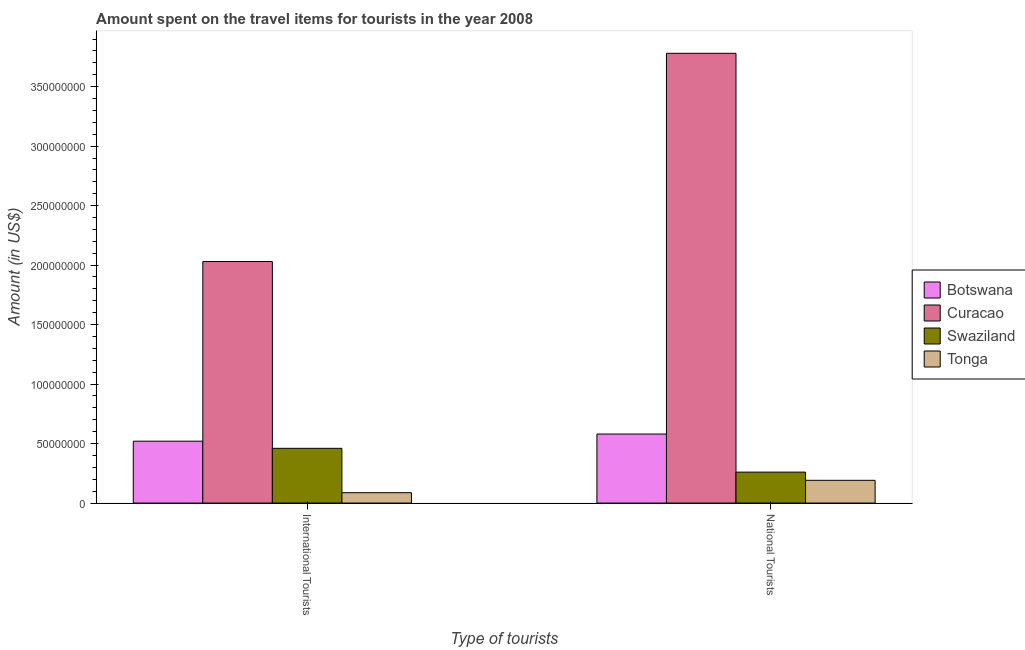How many different coloured bars are there?
Make the answer very short. 4. Are the number of bars on each tick of the X-axis equal?
Your response must be concise. Yes. How many bars are there on the 1st tick from the left?
Ensure brevity in your answer.  4. How many bars are there on the 2nd tick from the right?
Your answer should be very brief. 4. What is the label of the 2nd group of bars from the left?
Offer a terse response. National Tourists. What is the amount spent on travel items of national tourists in Swaziland?
Provide a succinct answer. 2.60e+07. Across all countries, what is the maximum amount spent on travel items of international tourists?
Provide a succinct answer. 2.03e+08. Across all countries, what is the minimum amount spent on travel items of international tourists?
Ensure brevity in your answer.  8.70e+06. In which country was the amount spent on travel items of national tourists maximum?
Keep it short and to the point. Curacao. In which country was the amount spent on travel items of national tourists minimum?
Provide a short and direct response. Tonga. What is the total amount spent on travel items of international tourists in the graph?
Your response must be concise. 3.10e+08. What is the difference between the amount spent on travel items of international tourists in Tonga and that in Swaziland?
Provide a short and direct response. -3.73e+07. What is the difference between the amount spent on travel items of national tourists in Curacao and the amount spent on travel items of international tourists in Botswana?
Give a very brief answer. 3.26e+08. What is the average amount spent on travel items of national tourists per country?
Ensure brevity in your answer.  1.20e+08. What is the difference between the amount spent on travel items of international tourists and amount spent on travel items of national tourists in Botswana?
Offer a very short reply. -6.00e+06. What is the ratio of the amount spent on travel items of international tourists in Swaziland to that in Tonga?
Provide a short and direct response. 5.29. Is the amount spent on travel items of international tourists in Botswana less than that in Tonga?
Offer a terse response. No. What does the 2nd bar from the left in International Tourists represents?
Ensure brevity in your answer.  Curacao. What does the 1st bar from the right in National Tourists represents?
Ensure brevity in your answer.  Tonga. Are all the bars in the graph horizontal?
Your answer should be very brief. No. How many countries are there in the graph?
Your answer should be very brief. 4. What is the difference between two consecutive major ticks on the Y-axis?
Provide a short and direct response. 5.00e+07. Where does the legend appear in the graph?
Your answer should be very brief. Center right. How many legend labels are there?
Your answer should be compact. 4. What is the title of the graph?
Provide a short and direct response. Amount spent on the travel items for tourists in the year 2008. Does "Ireland" appear as one of the legend labels in the graph?
Ensure brevity in your answer.  No. What is the label or title of the X-axis?
Provide a succinct answer. Type of tourists. What is the Amount (in US$) of Botswana in International Tourists?
Offer a very short reply. 5.20e+07. What is the Amount (in US$) in Curacao in International Tourists?
Provide a succinct answer. 2.03e+08. What is the Amount (in US$) of Swaziland in International Tourists?
Keep it short and to the point. 4.60e+07. What is the Amount (in US$) in Tonga in International Tourists?
Provide a succinct answer. 8.70e+06. What is the Amount (in US$) in Botswana in National Tourists?
Make the answer very short. 5.80e+07. What is the Amount (in US$) of Curacao in National Tourists?
Keep it short and to the point. 3.78e+08. What is the Amount (in US$) of Swaziland in National Tourists?
Provide a succinct answer. 2.60e+07. What is the Amount (in US$) of Tonga in National Tourists?
Your answer should be compact. 1.91e+07. Across all Type of tourists, what is the maximum Amount (in US$) of Botswana?
Provide a short and direct response. 5.80e+07. Across all Type of tourists, what is the maximum Amount (in US$) of Curacao?
Provide a succinct answer. 3.78e+08. Across all Type of tourists, what is the maximum Amount (in US$) of Swaziland?
Your answer should be very brief. 4.60e+07. Across all Type of tourists, what is the maximum Amount (in US$) of Tonga?
Your answer should be compact. 1.91e+07. Across all Type of tourists, what is the minimum Amount (in US$) in Botswana?
Provide a short and direct response. 5.20e+07. Across all Type of tourists, what is the minimum Amount (in US$) in Curacao?
Keep it short and to the point. 2.03e+08. Across all Type of tourists, what is the minimum Amount (in US$) in Swaziland?
Provide a succinct answer. 2.60e+07. Across all Type of tourists, what is the minimum Amount (in US$) in Tonga?
Your answer should be very brief. 8.70e+06. What is the total Amount (in US$) in Botswana in the graph?
Make the answer very short. 1.10e+08. What is the total Amount (in US$) in Curacao in the graph?
Ensure brevity in your answer.  5.81e+08. What is the total Amount (in US$) in Swaziland in the graph?
Offer a very short reply. 7.20e+07. What is the total Amount (in US$) of Tonga in the graph?
Make the answer very short. 2.78e+07. What is the difference between the Amount (in US$) in Botswana in International Tourists and that in National Tourists?
Give a very brief answer. -6.00e+06. What is the difference between the Amount (in US$) in Curacao in International Tourists and that in National Tourists?
Offer a very short reply. -1.75e+08. What is the difference between the Amount (in US$) of Tonga in International Tourists and that in National Tourists?
Keep it short and to the point. -1.04e+07. What is the difference between the Amount (in US$) of Botswana in International Tourists and the Amount (in US$) of Curacao in National Tourists?
Give a very brief answer. -3.26e+08. What is the difference between the Amount (in US$) in Botswana in International Tourists and the Amount (in US$) in Swaziland in National Tourists?
Make the answer very short. 2.60e+07. What is the difference between the Amount (in US$) in Botswana in International Tourists and the Amount (in US$) in Tonga in National Tourists?
Provide a succinct answer. 3.29e+07. What is the difference between the Amount (in US$) of Curacao in International Tourists and the Amount (in US$) of Swaziland in National Tourists?
Give a very brief answer. 1.77e+08. What is the difference between the Amount (in US$) in Curacao in International Tourists and the Amount (in US$) in Tonga in National Tourists?
Make the answer very short. 1.84e+08. What is the difference between the Amount (in US$) of Swaziland in International Tourists and the Amount (in US$) of Tonga in National Tourists?
Offer a terse response. 2.69e+07. What is the average Amount (in US$) of Botswana per Type of tourists?
Provide a short and direct response. 5.50e+07. What is the average Amount (in US$) of Curacao per Type of tourists?
Your answer should be compact. 2.90e+08. What is the average Amount (in US$) in Swaziland per Type of tourists?
Offer a terse response. 3.60e+07. What is the average Amount (in US$) of Tonga per Type of tourists?
Keep it short and to the point. 1.39e+07. What is the difference between the Amount (in US$) in Botswana and Amount (in US$) in Curacao in International Tourists?
Provide a succinct answer. -1.51e+08. What is the difference between the Amount (in US$) in Botswana and Amount (in US$) in Tonga in International Tourists?
Give a very brief answer. 4.33e+07. What is the difference between the Amount (in US$) in Curacao and Amount (in US$) in Swaziland in International Tourists?
Provide a short and direct response. 1.57e+08. What is the difference between the Amount (in US$) in Curacao and Amount (in US$) in Tonga in International Tourists?
Ensure brevity in your answer.  1.94e+08. What is the difference between the Amount (in US$) in Swaziland and Amount (in US$) in Tonga in International Tourists?
Provide a succinct answer. 3.73e+07. What is the difference between the Amount (in US$) in Botswana and Amount (in US$) in Curacao in National Tourists?
Provide a short and direct response. -3.20e+08. What is the difference between the Amount (in US$) of Botswana and Amount (in US$) of Swaziland in National Tourists?
Keep it short and to the point. 3.20e+07. What is the difference between the Amount (in US$) in Botswana and Amount (in US$) in Tonga in National Tourists?
Provide a short and direct response. 3.89e+07. What is the difference between the Amount (in US$) in Curacao and Amount (in US$) in Swaziland in National Tourists?
Give a very brief answer. 3.52e+08. What is the difference between the Amount (in US$) in Curacao and Amount (in US$) in Tonga in National Tourists?
Provide a short and direct response. 3.59e+08. What is the difference between the Amount (in US$) of Swaziland and Amount (in US$) of Tonga in National Tourists?
Provide a succinct answer. 6.90e+06. What is the ratio of the Amount (in US$) of Botswana in International Tourists to that in National Tourists?
Provide a short and direct response. 0.9. What is the ratio of the Amount (in US$) of Curacao in International Tourists to that in National Tourists?
Your response must be concise. 0.54. What is the ratio of the Amount (in US$) in Swaziland in International Tourists to that in National Tourists?
Keep it short and to the point. 1.77. What is the ratio of the Amount (in US$) of Tonga in International Tourists to that in National Tourists?
Provide a short and direct response. 0.46. What is the difference between the highest and the second highest Amount (in US$) of Curacao?
Offer a terse response. 1.75e+08. What is the difference between the highest and the second highest Amount (in US$) in Swaziland?
Offer a terse response. 2.00e+07. What is the difference between the highest and the second highest Amount (in US$) of Tonga?
Provide a short and direct response. 1.04e+07. What is the difference between the highest and the lowest Amount (in US$) in Curacao?
Offer a very short reply. 1.75e+08. What is the difference between the highest and the lowest Amount (in US$) of Tonga?
Ensure brevity in your answer.  1.04e+07. 